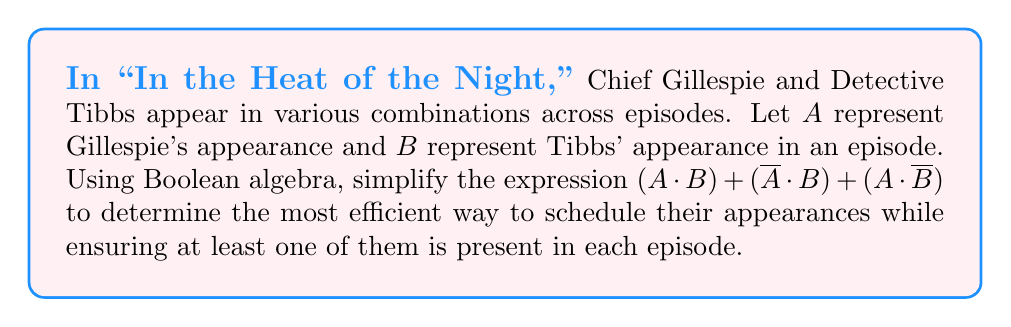Help me with this question. Let's simplify the expression step by step using Boolean algebra laws:

1) Start with the given expression:
   $$(A \cdot B) + (\overline{A} \cdot B) + (A \cdot \overline{B})$$

2) Apply the distributive law to factor out B from the first two terms:
   $$(A + \overline{A}) \cdot B + (A \cdot \overline{B})$$

3) Simplify $(A + \overline{A})$ using the complement law:
   $$1 \cdot B + (A \cdot \overline{B})$$

4) Simplify $1 \cdot B$ to just B:
   $$B + (A \cdot \overline{B})$$

5) Apply the distributive law again:
   $$B + A - (A \cdot B)$$

6) Rearrange the terms (commutative law):
   $$A + B - (A \cdot B)$$

7) This final expression, $A + B - (A \cdot B)$, is equivalent to the Boolean OR operation, often written as $A \lor B$.

This simplified expression means that for each episode, either Gillespie (A) or Tibbs (B) or both should appear, which is the most efficient way to ensure at least one of them is present in each episode.
Answer: $A \lor B$ 